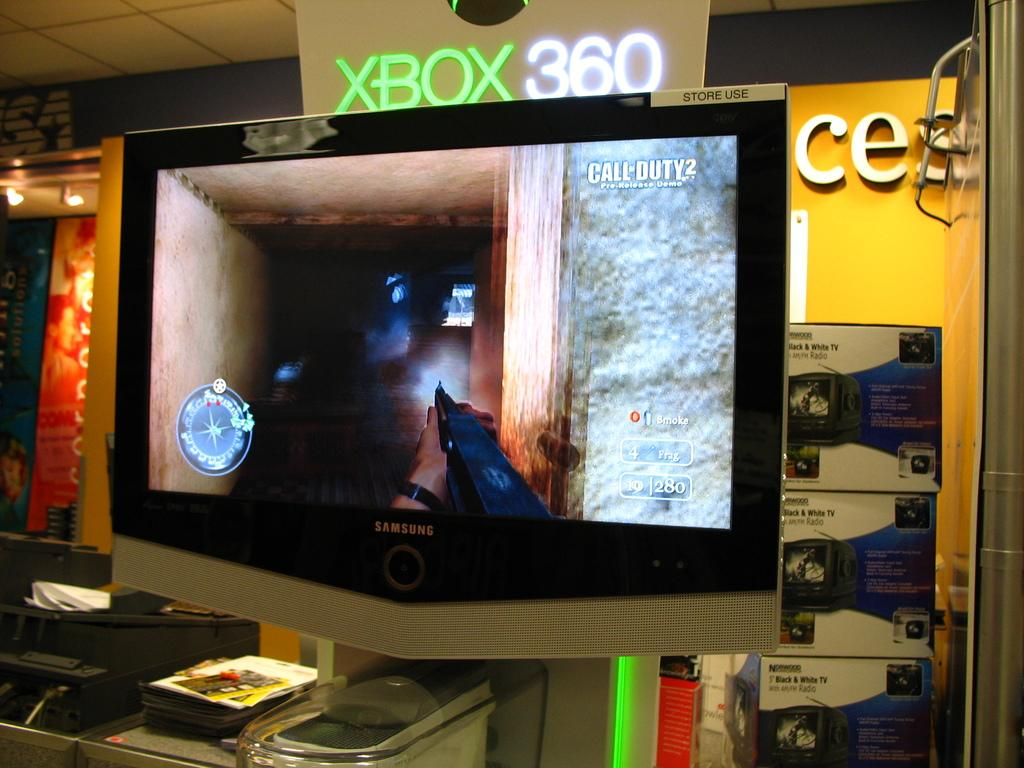<image>
Relay a brief, clear account of the picture shown. Call of Duty 2 displayed on a samsung TV that is for store use. 